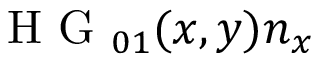<formula> <loc_0><loc_0><loc_500><loc_500>H G _ { 0 1 } ( x , y ) n _ { x }</formula> 